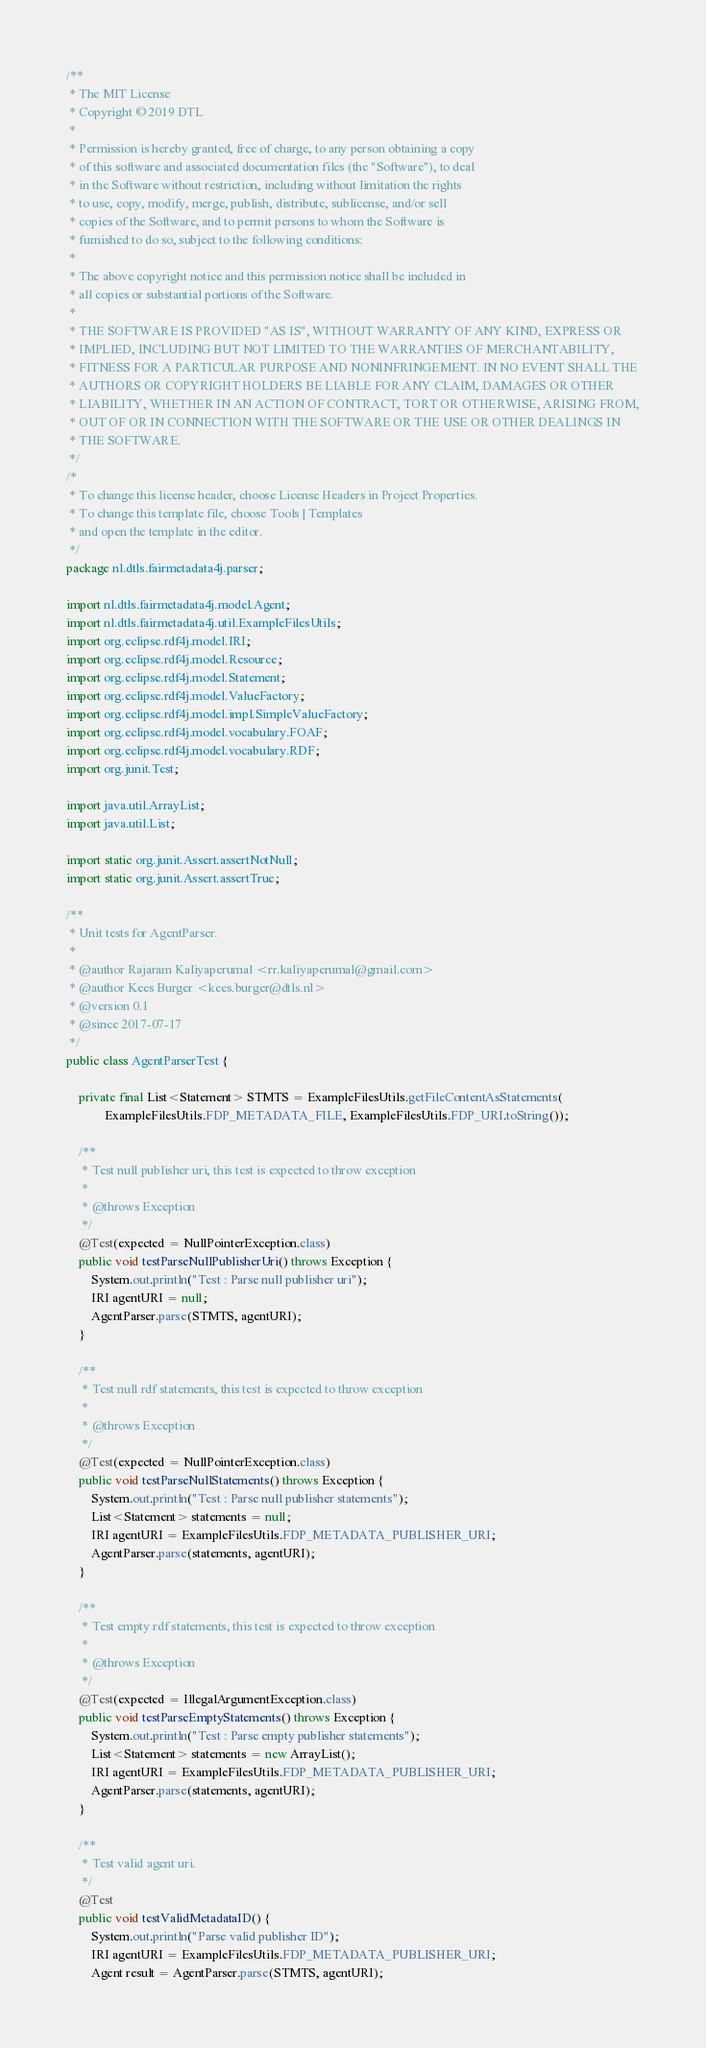<code> <loc_0><loc_0><loc_500><loc_500><_Java_>/**
 * The MIT License
 * Copyright © 2019 DTL
 *
 * Permission is hereby granted, free of charge, to any person obtaining a copy
 * of this software and associated documentation files (the "Software"), to deal
 * in the Software without restriction, including without limitation the rights
 * to use, copy, modify, merge, publish, distribute, sublicense, and/or sell
 * copies of the Software, and to permit persons to whom the Software is
 * furnished to do so, subject to the following conditions:
 *
 * The above copyright notice and this permission notice shall be included in
 * all copies or substantial portions of the Software.
 *
 * THE SOFTWARE IS PROVIDED "AS IS", WITHOUT WARRANTY OF ANY KIND, EXPRESS OR
 * IMPLIED, INCLUDING BUT NOT LIMITED TO THE WARRANTIES OF MERCHANTABILITY,
 * FITNESS FOR A PARTICULAR PURPOSE AND NONINFRINGEMENT. IN NO EVENT SHALL THE
 * AUTHORS OR COPYRIGHT HOLDERS BE LIABLE FOR ANY CLAIM, DAMAGES OR OTHER
 * LIABILITY, WHETHER IN AN ACTION OF CONTRACT, TORT OR OTHERWISE, ARISING FROM,
 * OUT OF OR IN CONNECTION WITH THE SOFTWARE OR THE USE OR OTHER DEALINGS IN
 * THE SOFTWARE.
 */
/*
 * To change this license header, choose License Headers in Project Properties.
 * To change this template file, choose Tools | Templates
 * and open the template in the editor.
 */
package nl.dtls.fairmetadata4j.parser;

import nl.dtls.fairmetadata4j.model.Agent;
import nl.dtls.fairmetadata4j.util.ExampleFilesUtils;
import org.eclipse.rdf4j.model.IRI;
import org.eclipse.rdf4j.model.Resource;
import org.eclipse.rdf4j.model.Statement;
import org.eclipse.rdf4j.model.ValueFactory;
import org.eclipse.rdf4j.model.impl.SimpleValueFactory;
import org.eclipse.rdf4j.model.vocabulary.FOAF;
import org.eclipse.rdf4j.model.vocabulary.RDF;
import org.junit.Test;

import java.util.ArrayList;
import java.util.List;

import static org.junit.Assert.assertNotNull;
import static org.junit.Assert.assertTrue;

/**
 * Unit tests for AgentParser.
 *
 * @author Rajaram Kaliyaperumal <rr.kaliyaperumal@gmail.com>
 * @author Kees Burger <kees.burger@dtls.nl>
 * @version 0.1
 * @since 2017-07-17
 */
public class AgentParserTest {

    private final List<Statement> STMTS = ExampleFilesUtils.getFileContentAsStatements(
            ExampleFilesUtils.FDP_METADATA_FILE, ExampleFilesUtils.FDP_URI.toString());

    /**
     * Test null publisher uri, this test is expected to throw exception
     *
     * @throws Exception
     */
    @Test(expected = NullPointerException.class)
    public void testParseNullPublisherUri() throws Exception {
        System.out.println("Test : Parse null publisher uri");
        IRI agentURI = null;
        AgentParser.parse(STMTS, agentURI);
    }

    /**
     * Test null rdf statements, this test is expected to throw exception
     *
     * @throws Exception
     */
    @Test(expected = NullPointerException.class)
    public void testParseNullStatements() throws Exception {
        System.out.println("Test : Parse null publisher statements");
        List<Statement> statements = null;
        IRI agentURI = ExampleFilesUtils.FDP_METADATA_PUBLISHER_URI;
        AgentParser.parse(statements, agentURI);
    }

    /**
     * Test empty rdf statements, this test is expected to throw exception
     *
     * @throws Exception
     */
    @Test(expected = IllegalArgumentException.class)
    public void testParseEmptyStatements() throws Exception {
        System.out.println("Test : Parse empty publisher statements");
        List<Statement> statements = new ArrayList();
        IRI agentURI = ExampleFilesUtils.FDP_METADATA_PUBLISHER_URI;
        AgentParser.parse(statements, agentURI);
    }

    /**
     * Test valid agent uri.
     */
    @Test
    public void testValidMetadataID() {
        System.out.println("Parse valid publisher ID");
        IRI agentURI = ExampleFilesUtils.FDP_METADATA_PUBLISHER_URI;
        Agent result = AgentParser.parse(STMTS, agentURI);</code> 